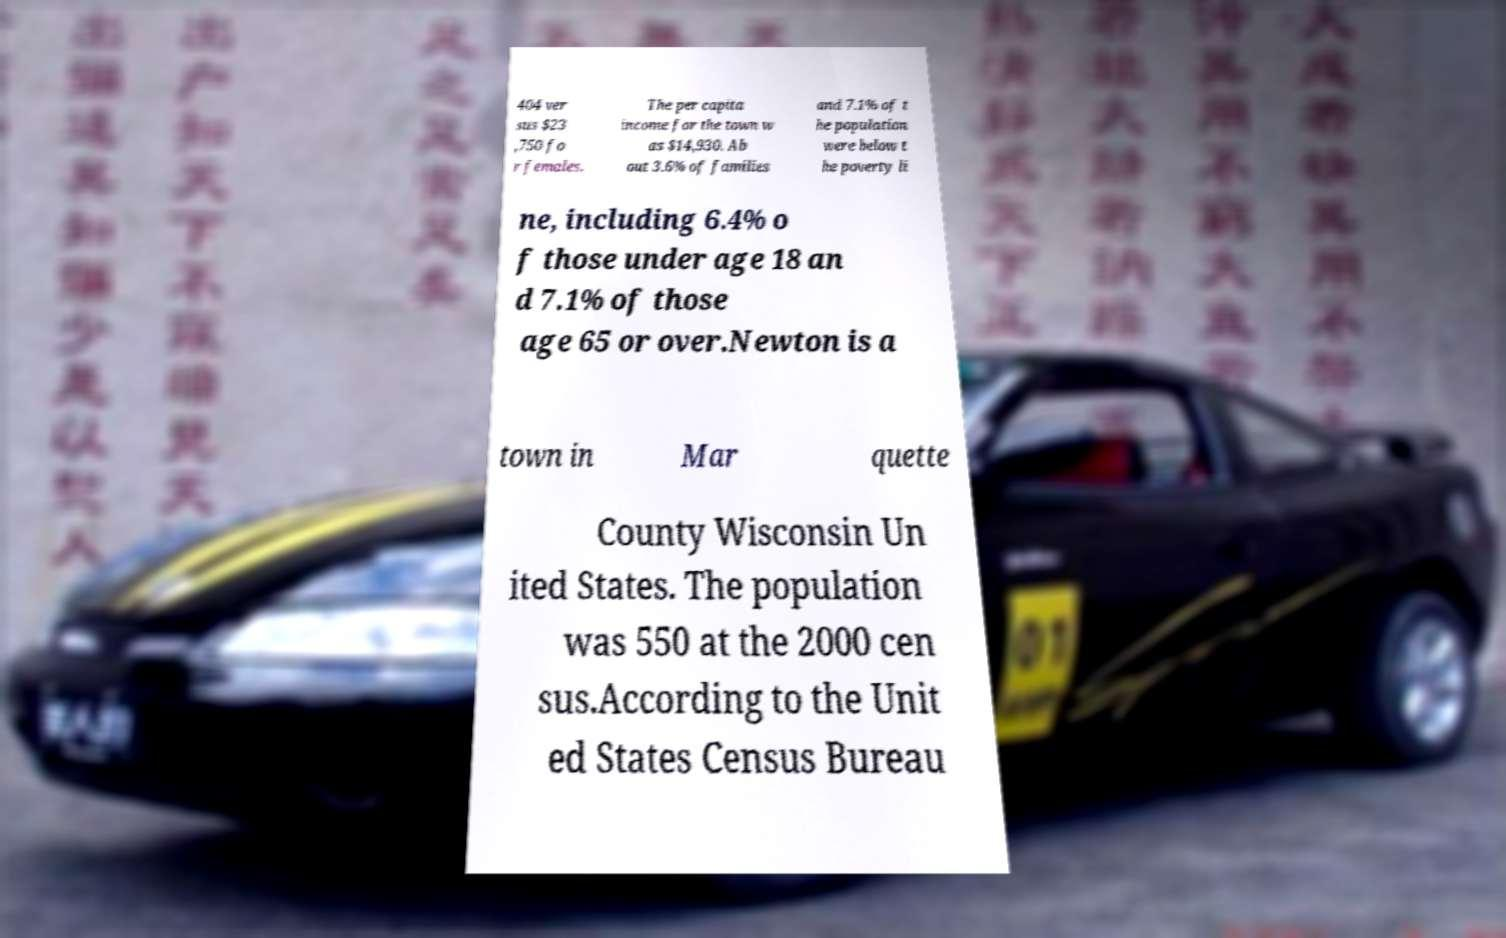Could you assist in decoding the text presented in this image and type it out clearly? 404 ver sus $23 ,750 fo r females. The per capita income for the town w as $14,930. Ab out 3.6% of families and 7.1% of t he population were below t he poverty li ne, including 6.4% o f those under age 18 an d 7.1% of those age 65 or over.Newton is a town in Mar quette County Wisconsin Un ited States. The population was 550 at the 2000 cen sus.According to the Unit ed States Census Bureau 